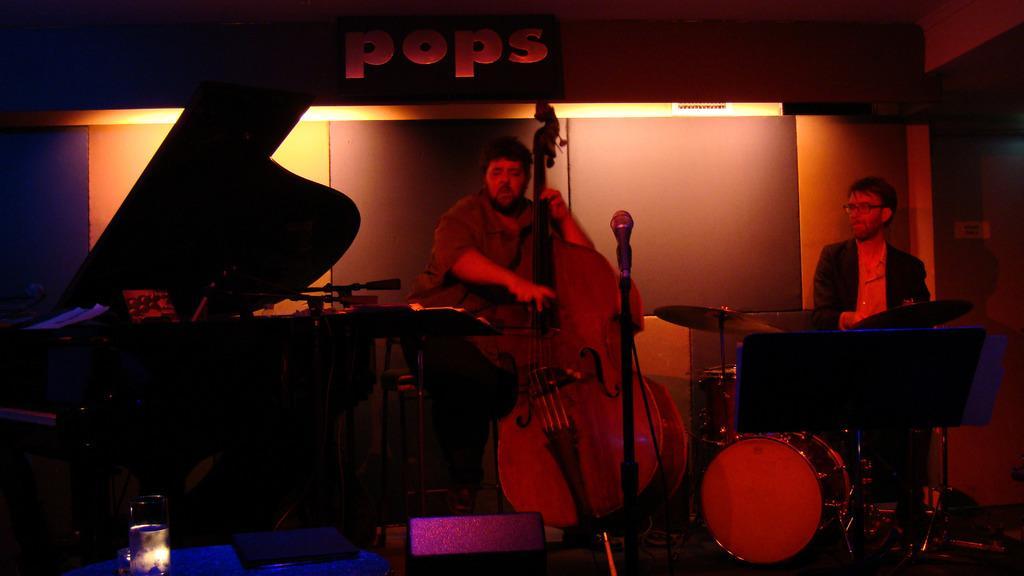Can you describe this image briefly? This man is standing and playing guitar. These are musical instruments. This man is playing this musical instruments. This is mic with holder. 